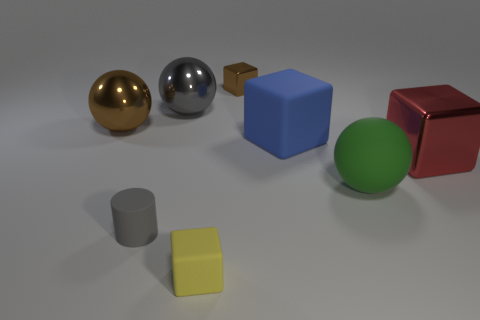Add 1 shiny things. How many objects exist? 9 Subtract all balls. How many objects are left? 5 Add 5 metallic balls. How many metallic balls exist? 7 Subtract 0 purple blocks. How many objects are left? 8 Subtract all brown things. Subtract all cyan balls. How many objects are left? 6 Add 8 green matte balls. How many green matte balls are left? 9 